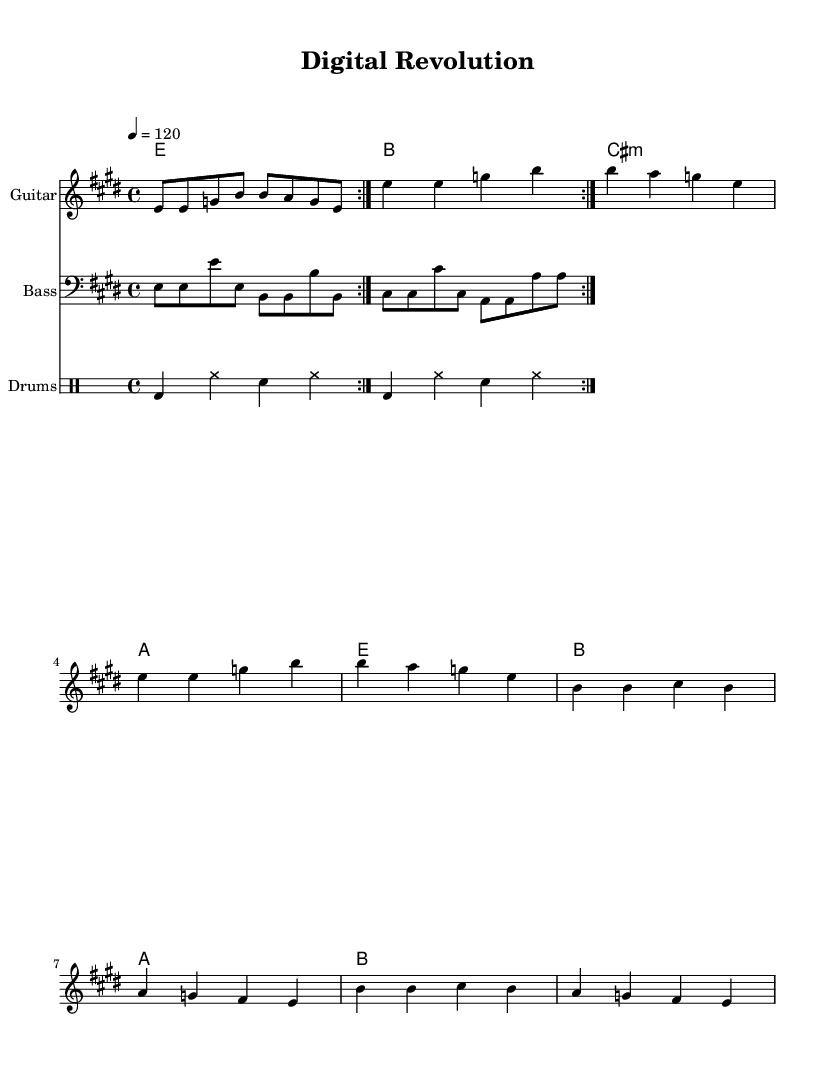What is the key signature of this music? The key signature is E major, which has four sharps: F sharp, C sharp, G sharp, and D sharp. This is indicated at the beginning of the staff.
Answer: E major What is the time signature of this piece? The time signature is 4/4, as it is specified at the beginning of the score and indicates that there are four beats per measure and each beat is a quarter note.
Answer: 4/4 What is the tempo of this song? The tempo marking indicates a speed of 120 beats per minute (BPM), which is mentioned in the global section. This means that there are two beats per second, giving the piece a moderate pace.
Answer: 120 How many measures are in the verse section? The verse section consists of eight measures, as each repeated section of the verse includes four measures, repeated twice. Counting those results in a total of eight measures overall.
Answer: 8 What type of lyrics are used in this piece? The lyrics consist of modern themes closely related to technology and the digital age, reflecting the content of the song through its words about bits, bytes, and digital revolution. This aligns with the rock genre's tendency to address current themes.
Answer: Technology-themed How many times is the guitar riff repeated? The guitar riff is marked to repeat two times, as indicated by the repeat volta symbol in the score, suggesting that the guitarist should play it twice in succession.
Answer: 2 What instrument is the bass written in? The bass part is written in a bass clef, as indicated in the score, which is commonly used for lower-pitched instruments like the bass guitar.
Answer: Bass clef 